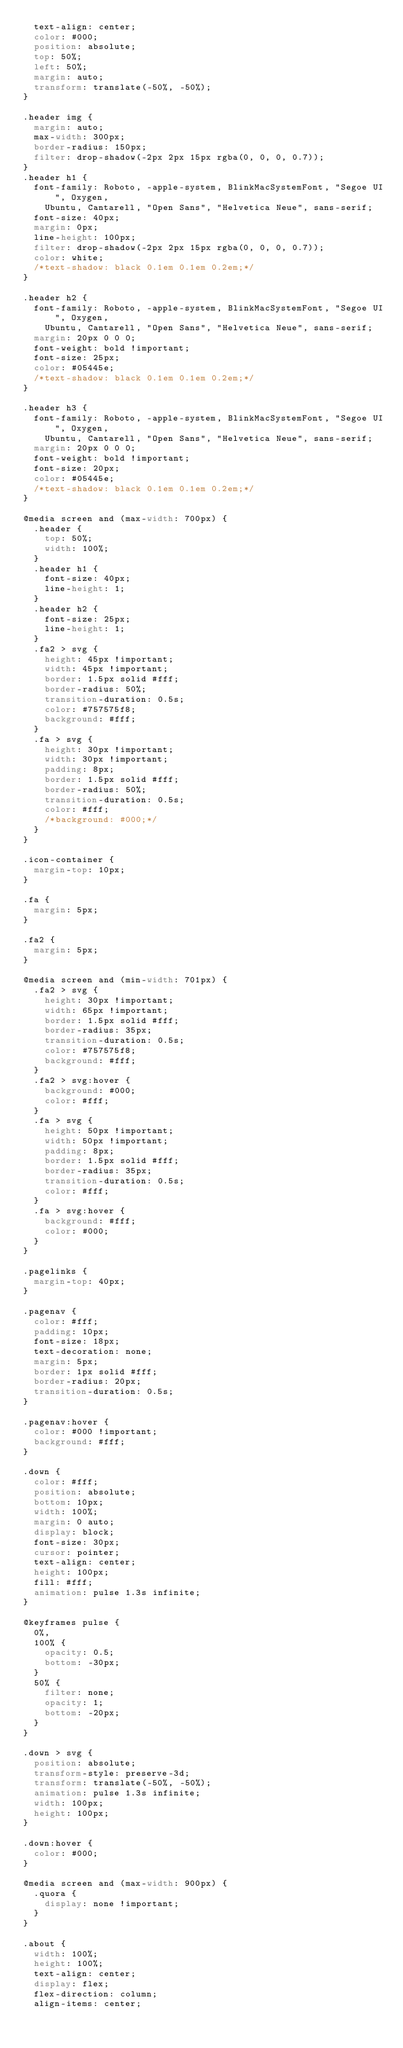<code> <loc_0><loc_0><loc_500><loc_500><_CSS_>  text-align: center;
  color: #000;
  position: absolute;
  top: 50%;
  left: 50%;
  margin: auto;
  transform: translate(-50%, -50%);  
}

.header img {
  margin: auto;
  max-width: 300px;
  border-radius: 150px;
  filter: drop-shadow(-2px 2px 15px rgba(0, 0, 0, 0.7));
}
.header h1 {
  font-family: Roboto, -apple-system, BlinkMacSystemFont, "Segoe UI", Oxygen,
    Ubuntu, Cantarell, "Open Sans", "Helvetica Neue", sans-serif;
  font-size: 40px;
  margin: 0px;
  line-height: 100px;
  filter: drop-shadow(-2px 2px 15px rgba(0, 0, 0, 0.7));
  color: white;
  /*text-shadow: black 0.1em 0.1em 0.2em;*/
}

.header h2 {
  font-family: Roboto, -apple-system, BlinkMacSystemFont, "Segoe UI", Oxygen,
    Ubuntu, Cantarell, "Open Sans", "Helvetica Neue", sans-serif;
  margin: 20px 0 0 0;
  font-weight: bold !important;
  font-size: 25px;
  color: #05445e;
  /*text-shadow: black 0.1em 0.1em 0.2em;*/
}

.header h3 {
  font-family: Roboto, -apple-system, BlinkMacSystemFont, "Segoe UI", Oxygen,
    Ubuntu, Cantarell, "Open Sans", "Helvetica Neue", sans-serif;
  margin: 20px 0 0 0;
  font-weight: bold !important;
  font-size: 20px;
  color: #05445e;
  /*text-shadow: black 0.1em 0.1em 0.2em;*/
}

@media screen and (max-width: 700px) {
  .header {
    top: 50%;
    width: 100%;
  }
  .header h1 {
    font-size: 40px;
    line-height: 1;
  }
  .header h2 {
    font-size: 25px;
    line-height: 1;
  }
  .fa2 > svg {
    height: 45px !important;
    width: 45px !important;
    border: 1.5px solid #fff;
    border-radius: 50%;
    transition-duration: 0.5s;
    color: #757575f8;
    background: #fff;
  }
  .fa > svg {
    height: 30px !important;
    width: 30px !important;
    padding: 8px;
    border: 1.5px solid #fff;
    border-radius: 50%;
    transition-duration: 0.5s;
    color: #fff;
    /*background: #000;*/
  }
}

.icon-container {
  margin-top: 10px;
}

.fa {
  margin: 5px;
}

.fa2 {
  margin: 5px;
}

@media screen and (min-width: 701px) {
  .fa2 > svg {
    height: 30px !important;
    width: 65px !important;
    border: 1.5px solid #fff;
    border-radius: 35px;
    transition-duration: 0.5s;
    color: #757575f8;
    background: #fff;
  }
  .fa2 > svg:hover {
    background: #000;
    color: #fff;
  }
  .fa > svg {
    height: 50px !important;
    width: 50px !important;
    padding: 8px;
    border: 1.5px solid #fff;
    border-radius: 35px;
    transition-duration: 0.5s;
    color: #fff;
  }
  .fa > svg:hover {
    background: #fff;
    color: #000;
  }
}

.pagelinks {
  margin-top: 40px;
}

.pagenav {
  color: #fff;
  padding: 10px;
  font-size: 18px;
  text-decoration: none;
  margin: 5px;
  border: 1px solid #fff;
  border-radius: 20px;
  transition-duration: 0.5s;
}

.pagenav:hover {
  color: #000 !important;
  background: #fff;
}

.down {
  color: #fff;
  position: absolute;
  bottom: 10px;
  width: 100%;
  margin: 0 auto;
  display: block;
  font-size: 30px;
  cursor: pointer;
  text-align: center;
  height: 100px;
  fill: #fff;
  animation: pulse 1.3s infinite;
}

@keyframes pulse {
  0%,
  100% {
    opacity: 0.5;
    bottom: -30px;
  }
  50% {
    filter: none;
    opacity: 1;
    bottom: -20px;
  }
}

.down > svg {
  position: absolute;
  transform-style: preserve-3d;
  transform: translate(-50%, -50%);
  animation: pulse 1.3s infinite;
  width: 100px;
  height: 100px;
}

.down:hover {
  color: #000;
}

@media screen and (max-width: 900px) {
  .quora {
    display: none !important;
  }
}

.about {
  width: 100%;
  height: 100%;
  text-align: center;
  display: flex;
  flex-direction: column;
  align-items: center;</code> 